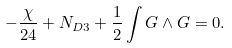<formula> <loc_0><loc_0><loc_500><loc_500>- \frac { \chi } { 2 4 } + N _ { D 3 } + \frac { 1 } { 2 } \int G \wedge G = 0 .</formula> 